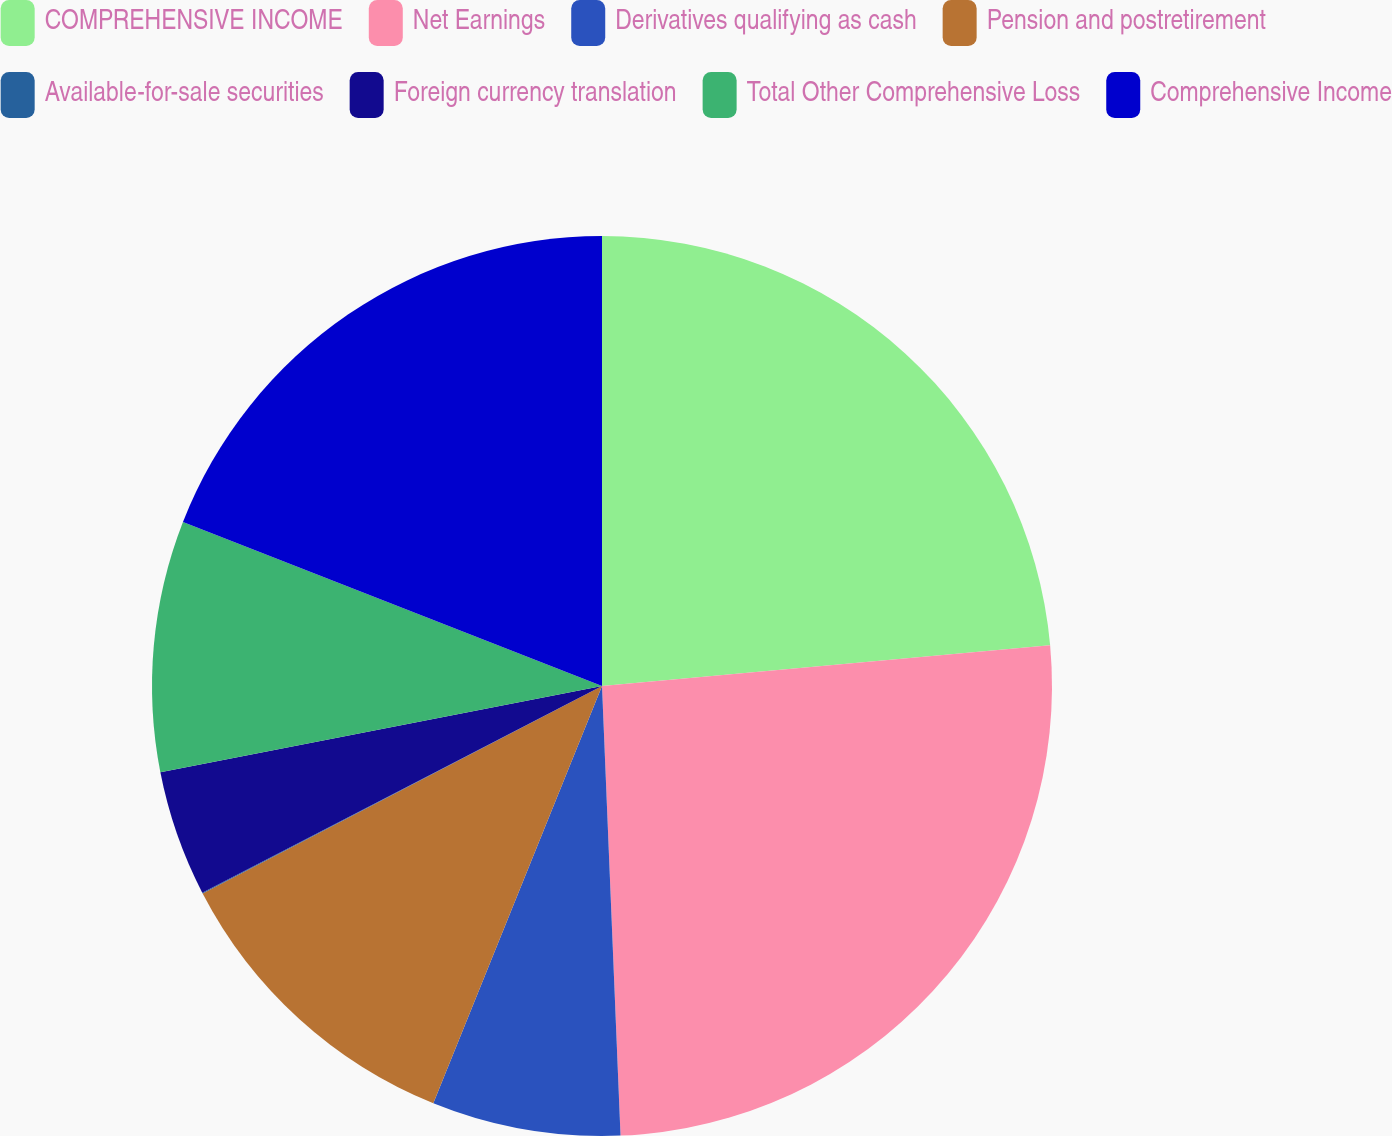Convert chart. <chart><loc_0><loc_0><loc_500><loc_500><pie_chart><fcel>COMPREHENSIVE INCOME<fcel>Net Earnings<fcel>Derivatives qualifying as cash<fcel>Pension and postretirement<fcel>Available-for-sale securities<fcel>Foreign currency translation<fcel>Total Other Comprehensive Loss<fcel>Comprehensive Income<nl><fcel>23.55%<fcel>25.79%<fcel>6.77%<fcel>11.26%<fcel>0.03%<fcel>4.52%<fcel>9.01%<fcel>19.06%<nl></chart> 